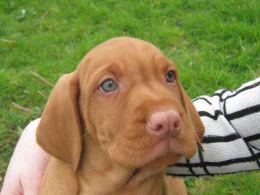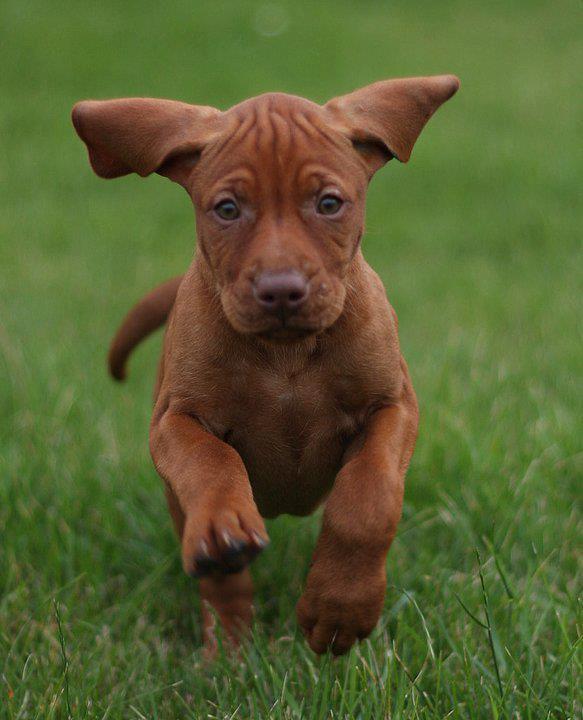The first image is the image on the left, the second image is the image on the right. For the images shown, is this caption "A dog has something in its mouth in the right image." true? Answer yes or no. No. The first image is the image on the left, the second image is the image on the right. Assess this claim about the two images: "The dog in the left image is standing on all fours on grass with its body in profile, and the dog on the right has its body turned leftward.". Correct or not? Answer yes or no. No. 